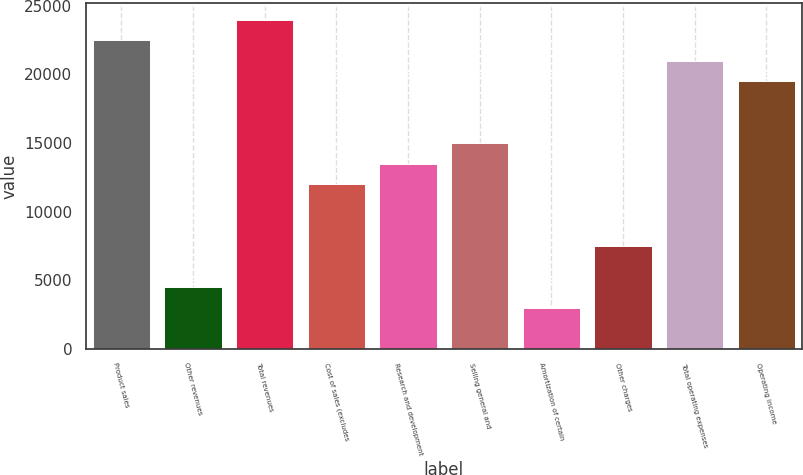Convert chart. <chart><loc_0><loc_0><loc_500><loc_500><bar_chart><fcel>Product sales<fcel>Other revenues<fcel>Total revenues<fcel>Cost of sales (excludes<fcel>Research and development<fcel>Selling general and<fcel>Amortization of certain<fcel>Other charges<fcel>Total operating expenses<fcel>Operating income<nl><fcel>22502.6<fcel>4503.53<fcel>24002.5<fcel>12003.1<fcel>13503<fcel>15003<fcel>3003.61<fcel>7503.37<fcel>21002.7<fcel>19502.7<nl></chart> 